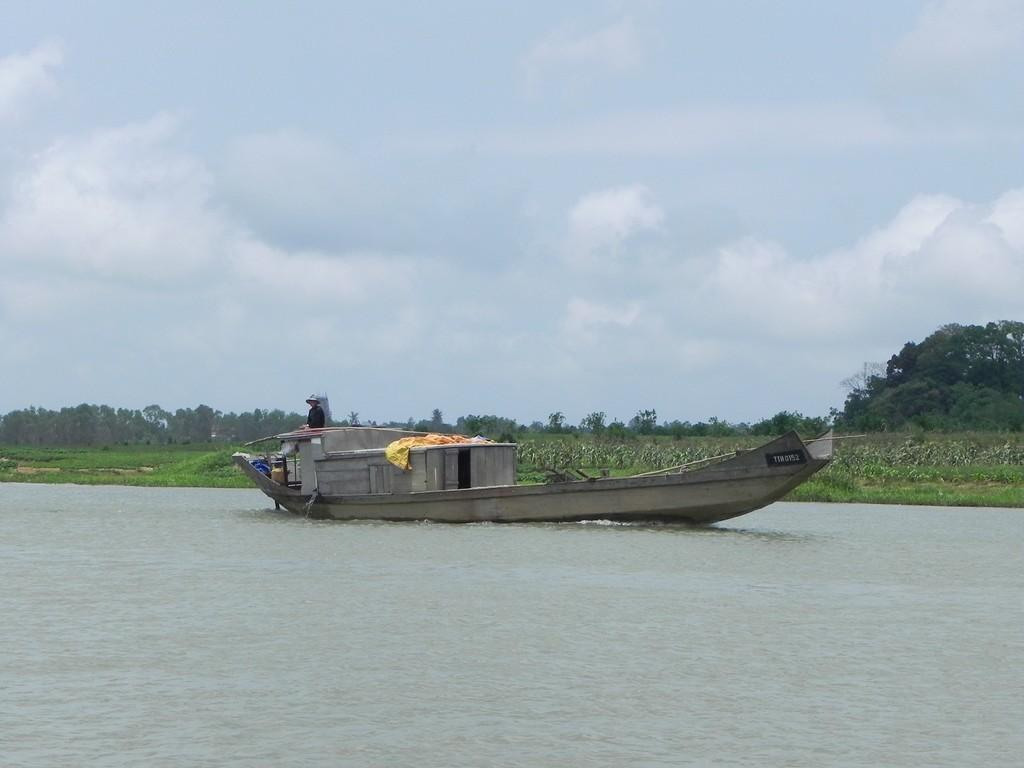What is: What is the main subject of the image? The main subject of the image is a boat. What is the boat doing in the image? The boat is floating on the water. What can be seen on the ground in the image? There is grass on the ground. What is visible in the background of the image? There are trees and the sky in the background of the image. What is present in the sky? Clouds are present in the sky. Where is the kettle located in the image? There is no kettle present in the image. What type of zephyr can be seen blowing through the trees in the image? There is no zephyr mentioned or depicted in the image; it is a term used to describe a gentle breeze, and there is no indication of wind in the image. 